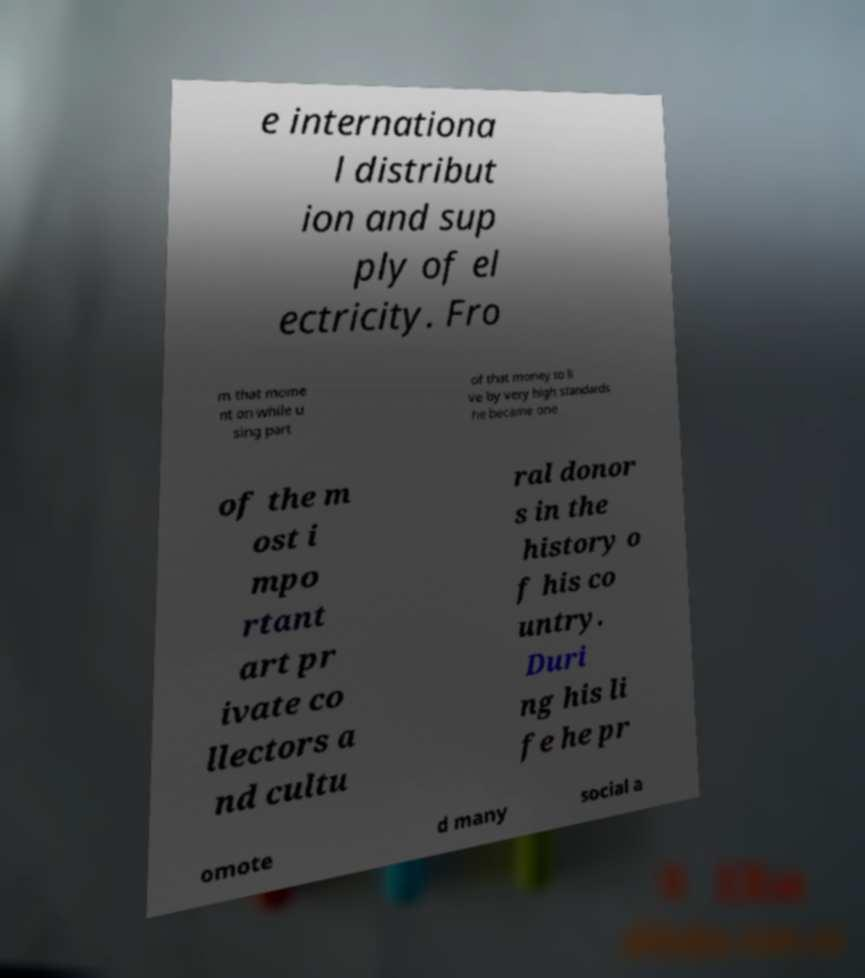I need the written content from this picture converted into text. Can you do that? e internationa l distribut ion and sup ply of el ectricity. Fro m that mome nt on while u sing part of that money to li ve by very high standards he became one of the m ost i mpo rtant art pr ivate co llectors a nd cultu ral donor s in the history o f his co untry. Duri ng his li fe he pr omote d many social a 